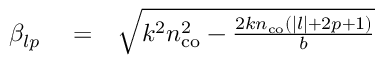<formula> <loc_0><loc_0><loc_500><loc_500>\begin{array} { r l r } { \beta _ { l p } } & = } & { \sqrt { k ^ { 2 } n _ { c o } ^ { 2 } - \frac { 2 k n _ { c o } ( | l | + 2 p + 1 ) } { b } } } \end{array}</formula> 